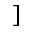<formula> <loc_0><loc_0><loc_500><loc_500>]</formula> 